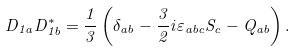Convert formula to latex. <formula><loc_0><loc_0><loc_500><loc_500>D _ { 1 a } D _ { 1 b } ^ { * } = \frac { 1 } { 3 } \left ( \delta _ { a b } - \frac { 3 } { 2 } i \varepsilon _ { a b c } S _ { c } - Q _ { a b } \right ) .</formula> 